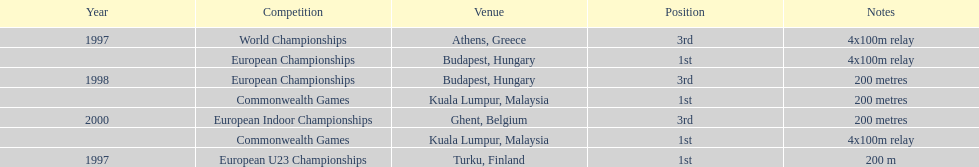In budapest, hungary, how many events occurred and secured the top position? 1. 